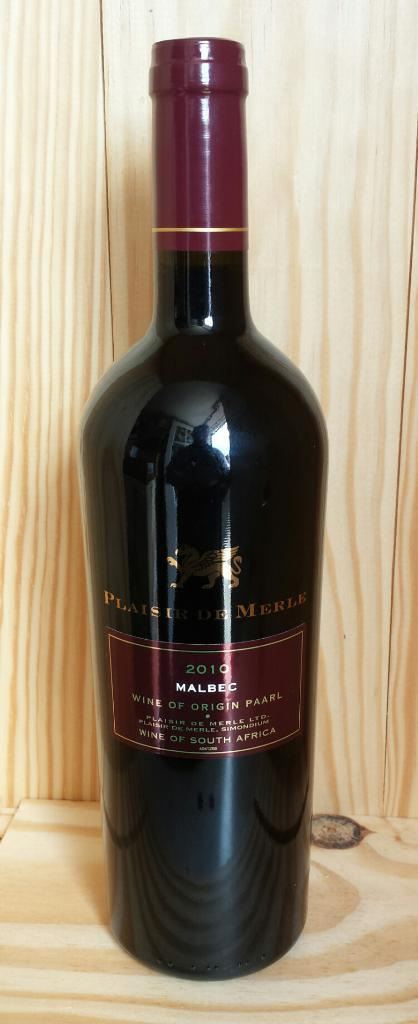<image>
Summarize the visual content of the image. 2010 Malbec sits alone on a wooden shelf 